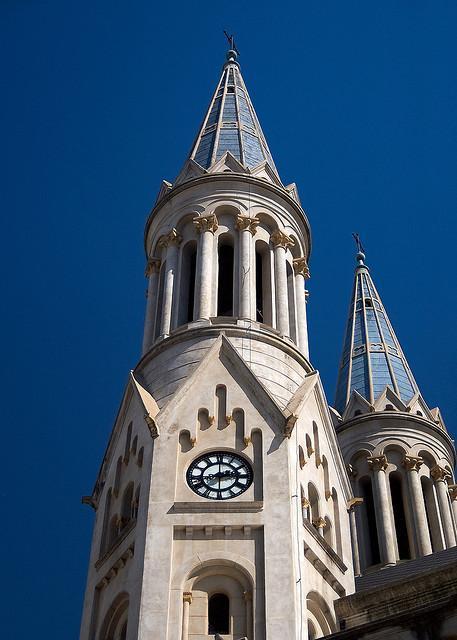How many dogs are there left to the lady?
Give a very brief answer. 0. 